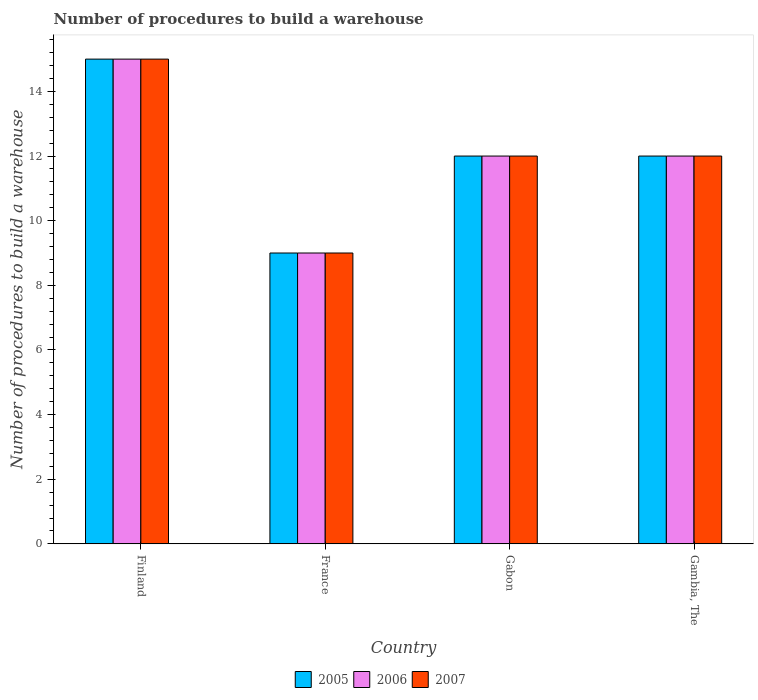How many different coloured bars are there?
Keep it short and to the point. 3. How many bars are there on the 1st tick from the left?
Offer a very short reply. 3. Across all countries, what is the minimum number of procedures to build a warehouse in in 2007?
Your answer should be compact. 9. In which country was the number of procedures to build a warehouse in in 2006 minimum?
Keep it short and to the point. France. In how many countries, is the number of procedures to build a warehouse in in 2005 greater than 7.2?
Your response must be concise. 4. What is the ratio of the number of procedures to build a warehouse in in 2006 in Finland to that in France?
Your answer should be very brief. 1.67. Is the number of procedures to build a warehouse in in 2005 in Finland less than that in Gabon?
Offer a very short reply. No. Is the difference between the number of procedures to build a warehouse in in 2005 in Finland and Gambia, The greater than the difference between the number of procedures to build a warehouse in in 2006 in Finland and Gambia, The?
Make the answer very short. No. What is the difference between the highest and the lowest number of procedures to build a warehouse in in 2006?
Ensure brevity in your answer.  6. Is it the case that in every country, the sum of the number of procedures to build a warehouse in in 2006 and number of procedures to build a warehouse in in 2007 is greater than the number of procedures to build a warehouse in in 2005?
Offer a terse response. Yes. How many bars are there?
Your answer should be compact. 12. Are all the bars in the graph horizontal?
Offer a terse response. No. How many countries are there in the graph?
Your response must be concise. 4. Does the graph contain any zero values?
Ensure brevity in your answer.  No. How many legend labels are there?
Offer a very short reply. 3. What is the title of the graph?
Provide a short and direct response. Number of procedures to build a warehouse. What is the label or title of the Y-axis?
Give a very brief answer. Number of procedures to build a warehouse. What is the Number of procedures to build a warehouse in 2005 in Finland?
Your response must be concise. 15. What is the Number of procedures to build a warehouse in 2006 in Finland?
Provide a succinct answer. 15. What is the Number of procedures to build a warehouse in 2007 in Finland?
Make the answer very short. 15. What is the Number of procedures to build a warehouse of 2006 in France?
Your response must be concise. 9. What is the Number of procedures to build a warehouse of 2007 in France?
Provide a succinct answer. 9. What is the Number of procedures to build a warehouse of 2005 in Gabon?
Ensure brevity in your answer.  12. What is the Number of procedures to build a warehouse of 2006 in Gabon?
Your response must be concise. 12. What is the Number of procedures to build a warehouse in 2006 in Gambia, The?
Provide a succinct answer. 12. Across all countries, what is the maximum Number of procedures to build a warehouse of 2005?
Provide a succinct answer. 15. Across all countries, what is the maximum Number of procedures to build a warehouse of 2006?
Your answer should be very brief. 15. Across all countries, what is the maximum Number of procedures to build a warehouse of 2007?
Give a very brief answer. 15. What is the total Number of procedures to build a warehouse of 2005 in the graph?
Offer a terse response. 48. What is the total Number of procedures to build a warehouse of 2006 in the graph?
Provide a short and direct response. 48. What is the total Number of procedures to build a warehouse of 2007 in the graph?
Make the answer very short. 48. What is the difference between the Number of procedures to build a warehouse in 2005 in Finland and that in France?
Your answer should be compact. 6. What is the difference between the Number of procedures to build a warehouse in 2006 in Finland and that in France?
Your response must be concise. 6. What is the difference between the Number of procedures to build a warehouse of 2005 in France and that in Gabon?
Keep it short and to the point. -3. What is the difference between the Number of procedures to build a warehouse of 2006 in France and that in Gabon?
Offer a very short reply. -3. What is the difference between the Number of procedures to build a warehouse in 2005 in France and that in Gambia, The?
Ensure brevity in your answer.  -3. What is the difference between the Number of procedures to build a warehouse of 2006 in Gabon and that in Gambia, The?
Provide a succinct answer. 0. What is the difference between the Number of procedures to build a warehouse in 2007 in Gabon and that in Gambia, The?
Give a very brief answer. 0. What is the difference between the Number of procedures to build a warehouse of 2005 in Finland and the Number of procedures to build a warehouse of 2006 in France?
Your response must be concise. 6. What is the difference between the Number of procedures to build a warehouse in 2005 in Finland and the Number of procedures to build a warehouse in 2007 in France?
Your response must be concise. 6. What is the difference between the Number of procedures to build a warehouse in 2006 in Finland and the Number of procedures to build a warehouse in 2007 in Gabon?
Offer a terse response. 3. What is the difference between the Number of procedures to build a warehouse in 2005 in Finland and the Number of procedures to build a warehouse in 2007 in Gambia, The?
Your answer should be compact. 3. What is the difference between the Number of procedures to build a warehouse in 2005 in France and the Number of procedures to build a warehouse in 2007 in Gabon?
Your answer should be compact. -3. What is the difference between the Number of procedures to build a warehouse of 2006 in France and the Number of procedures to build a warehouse of 2007 in Gabon?
Your answer should be very brief. -3. What is the difference between the Number of procedures to build a warehouse of 2005 in France and the Number of procedures to build a warehouse of 2006 in Gambia, The?
Provide a short and direct response. -3. What is the difference between the Number of procedures to build a warehouse of 2005 in France and the Number of procedures to build a warehouse of 2007 in Gambia, The?
Offer a very short reply. -3. What is the difference between the Number of procedures to build a warehouse in 2005 in Gabon and the Number of procedures to build a warehouse in 2007 in Gambia, The?
Your answer should be compact. 0. What is the average Number of procedures to build a warehouse in 2007 per country?
Your response must be concise. 12. What is the difference between the Number of procedures to build a warehouse of 2005 and Number of procedures to build a warehouse of 2007 in Finland?
Your answer should be very brief. 0. What is the difference between the Number of procedures to build a warehouse in 2005 and Number of procedures to build a warehouse in 2007 in Gabon?
Keep it short and to the point. 0. What is the difference between the Number of procedures to build a warehouse of 2005 and Number of procedures to build a warehouse of 2006 in Gambia, The?
Offer a terse response. 0. What is the difference between the Number of procedures to build a warehouse of 2005 and Number of procedures to build a warehouse of 2007 in Gambia, The?
Your response must be concise. 0. What is the ratio of the Number of procedures to build a warehouse of 2005 in Finland to that in France?
Provide a short and direct response. 1.67. What is the ratio of the Number of procedures to build a warehouse in 2006 in Finland to that in France?
Make the answer very short. 1.67. What is the ratio of the Number of procedures to build a warehouse of 2007 in Finland to that in France?
Offer a very short reply. 1.67. What is the ratio of the Number of procedures to build a warehouse in 2006 in Finland to that in Gabon?
Give a very brief answer. 1.25. What is the ratio of the Number of procedures to build a warehouse in 2005 in Finland to that in Gambia, The?
Make the answer very short. 1.25. What is the ratio of the Number of procedures to build a warehouse of 2006 in Finland to that in Gambia, The?
Give a very brief answer. 1.25. What is the ratio of the Number of procedures to build a warehouse in 2007 in Finland to that in Gambia, The?
Make the answer very short. 1.25. What is the ratio of the Number of procedures to build a warehouse in 2006 in France to that in Gambia, The?
Give a very brief answer. 0.75. What is the difference between the highest and the second highest Number of procedures to build a warehouse in 2006?
Provide a succinct answer. 3. What is the difference between the highest and the lowest Number of procedures to build a warehouse in 2005?
Ensure brevity in your answer.  6. What is the difference between the highest and the lowest Number of procedures to build a warehouse in 2006?
Your answer should be compact. 6. What is the difference between the highest and the lowest Number of procedures to build a warehouse of 2007?
Make the answer very short. 6. 